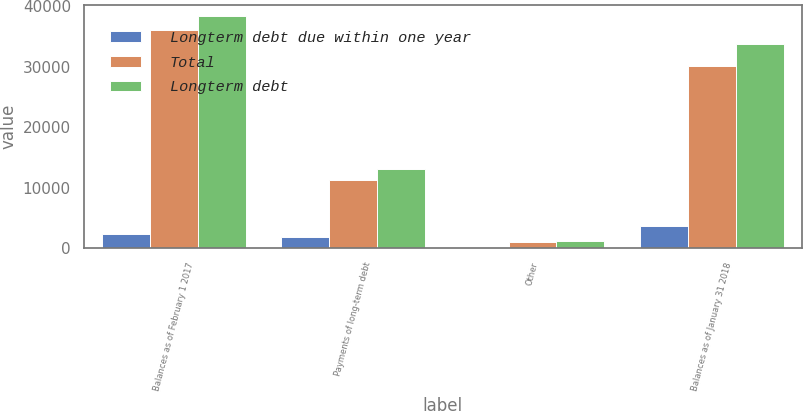Convert chart to OTSL. <chart><loc_0><loc_0><loc_500><loc_500><stacked_bar_chart><ecel><fcel>Balances as of February 1 2017<fcel>Payments of long-term debt<fcel>Other<fcel>Balances as of January 31 2018<nl><fcel>Longterm debt due within one year<fcel>2256<fcel>1789<fcel>47<fcel>3738<nl><fcel>Total<fcel>36015<fcel>11272<fcel>1050<fcel>30045<nl><fcel>Longterm debt<fcel>38271<fcel>13061<fcel>1097<fcel>33783<nl></chart> 